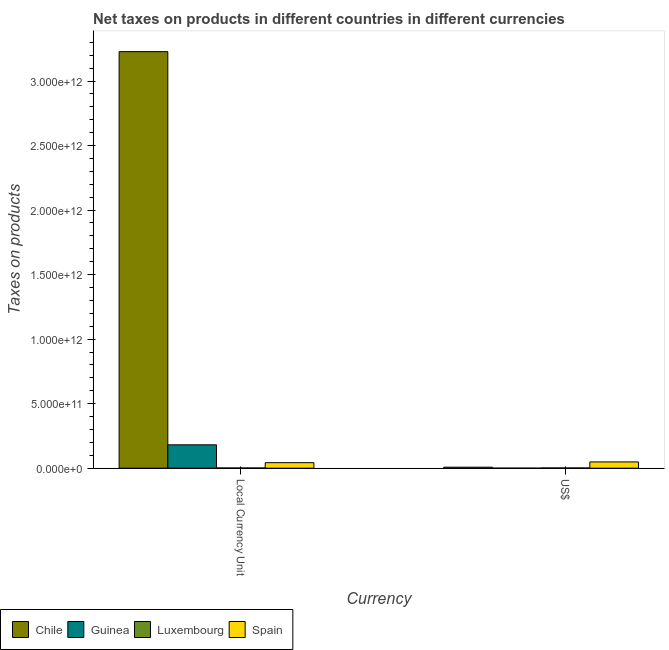How many groups of bars are there?
Your answer should be compact. 2. What is the label of the 2nd group of bars from the left?
Your answer should be very brief. US$. What is the net taxes in us$ in Guinea?
Provide a succinct answer. 1.65e+08. Across all countries, what is the maximum net taxes in us$?
Give a very brief answer. 4.86e+1. Across all countries, what is the minimum net taxes in us$?
Your answer should be very brief. 1.65e+08. In which country was the net taxes in us$ maximum?
Offer a very short reply. Spain. In which country was the net taxes in us$ minimum?
Provide a succinct answer. Guinea. What is the total net taxes in constant 2005 us$ in the graph?
Your response must be concise. 3.45e+12. What is the difference between the net taxes in constant 2005 us$ in Guinea and that in Chile?
Provide a short and direct response. -3.05e+12. What is the difference between the net taxes in us$ in Chile and the net taxes in constant 2005 us$ in Guinea?
Give a very brief answer. -1.73e+11. What is the average net taxes in constant 2005 us$ per country?
Provide a succinct answer. 8.63e+11. What is the difference between the net taxes in us$ and net taxes in constant 2005 us$ in Guinea?
Your answer should be compact. -1.81e+11. In how many countries, is the net taxes in us$ greater than 200000000000 units?
Offer a very short reply. 0. What is the ratio of the net taxes in us$ in Chile to that in Luxembourg?
Ensure brevity in your answer.  4.13. Is the net taxes in constant 2005 us$ in Spain less than that in Guinea?
Ensure brevity in your answer.  Yes. In how many countries, is the net taxes in us$ greater than the average net taxes in us$ taken over all countries?
Give a very brief answer. 1. What does the 1st bar from the left in Local Currency Unit represents?
Keep it short and to the point. Chile. What does the 2nd bar from the right in US$ represents?
Offer a very short reply. Luxembourg. Are all the bars in the graph horizontal?
Keep it short and to the point. No. How many countries are there in the graph?
Your answer should be very brief. 4. What is the difference between two consecutive major ticks on the Y-axis?
Offer a terse response. 5.00e+11. Where does the legend appear in the graph?
Keep it short and to the point. Bottom left. How are the legend labels stacked?
Offer a very short reply. Horizontal. What is the title of the graph?
Provide a succinct answer. Net taxes on products in different countries in different currencies. What is the label or title of the X-axis?
Give a very brief answer. Currency. What is the label or title of the Y-axis?
Offer a very short reply. Taxes on products. What is the Taxes on products in Chile in Local Currency Unit?
Your answer should be compact. 3.23e+12. What is the Taxes on products of Guinea in Local Currency Unit?
Make the answer very short. 1.81e+11. What is the Taxes on products of Luxembourg in Local Currency Unit?
Keep it short and to the point. 1.65e+09. What is the Taxes on products of Spain in Local Currency Unit?
Offer a terse response. 4.27e+1. What is the Taxes on products in Chile in US$?
Make the answer very short. 7.70e+09. What is the Taxes on products in Guinea in US$?
Provide a short and direct response. 1.65e+08. What is the Taxes on products in Luxembourg in US$?
Provide a short and direct response. 1.87e+09. What is the Taxes on products of Spain in US$?
Your answer should be compact. 4.86e+1. Across all Currency, what is the maximum Taxes on products in Chile?
Make the answer very short. 3.23e+12. Across all Currency, what is the maximum Taxes on products of Guinea?
Keep it short and to the point. 1.81e+11. Across all Currency, what is the maximum Taxes on products of Luxembourg?
Ensure brevity in your answer.  1.87e+09. Across all Currency, what is the maximum Taxes on products of Spain?
Ensure brevity in your answer.  4.86e+1. Across all Currency, what is the minimum Taxes on products in Chile?
Keep it short and to the point. 7.70e+09. Across all Currency, what is the minimum Taxes on products of Guinea?
Make the answer very short. 1.65e+08. Across all Currency, what is the minimum Taxes on products in Luxembourg?
Provide a short and direct response. 1.65e+09. Across all Currency, what is the minimum Taxes on products of Spain?
Your answer should be compact. 4.27e+1. What is the total Taxes on products in Chile in the graph?
Provide a succinct answer. 3.24e+12. What is the total Taxes on products of Guinea in the graph?
Keep it short and to the point. 1.81e+11. What is the total Taxes on products of Luxembourg in the graph?
Keep it short and to the point. 3.52e+09. What is the total Taxes on products in Spain in the graph?
Give a very brief answer. 9.13e+1. What is the difference between the Taxes on products of Chile in Local Currency Unit and that in US$?
Provide a succinct answer. 3.22e+12. What is the difference between the Taxes on products in Guinea in Local Currency Unit and that in US$?
Give a very brief answer. 1.81e+11. What is the difference between the Taxes on products of Luxembourg in Local Currency Unit and that in US$?
Your answer should be very brief. -2.11e+08. What is the difference between the Taxes on products of Spain in Local Currency Unit and that in US$?
Keep it short and to the point. -5.83e+09. What is the difference between the Taxes on products of Chile in Local Currency Unit and the Taxes on products of Guinea in US$?
Keep it short and to the point. 3.23e+12. What is the difference between the Taxes on products in Chile in Local Currency Unit and the Taxes on products in Luxembourg in US$?
Keep it short and to the point. 3.23e+12. What is the difference between the Taxes on products of Chile in Local Currency Unit and the Taxes on products of Spain in US$?
Give a very brief answer. 3.18e+12. What is the difference between the Taxes on products of Guinea in Local Currency Unit and the Taxes on products of Luxembourg in US$?
Your answer should be compact. 1.79e+11. What is the difference between the Taxes on products of Guinea in Local Currency Unit and the Taxes on products of Spain in US$?
Provide a short and direct response. 1.33e+11. What is the difference between the Taxes on products in Luxembourg in Local Currency Unit and the Taxes on products in Spain in US$?
Keep it short and to the point. -4.69e+1. What is the average Taxes on products in Chile per Currency?
Make the answer very short. 1.62e+12. What is the average Taxes on products in Guinea per Currency?
Your response must be concise. 9.06e+1. What is the average Taxes on products in Luxembourg per Currency?
Your answer should be compact. 1.76e+09. What is the average Taxes on products of Spain per Currency?
Your answer should be compact. 4.57e+1. What is the difference between the Taxes on products of Chile and Taxes on products of Guinea in Local Currency Unit?
Provide a short and direct response. 3.05e+12. What is the difference between the Taxes on products of Chile and Taxes on products of Luxembourg in Local Currency Unit?
Provide a short and direct response. 3.23e+12. What is the difference between the Taxes on products in Chile and Taxes on products in Spain in Local Currency Unit?
Ensure brevity in your answer.  3.18e+12. What is the difference between the Taxes on products in Guinea and Taxes on products in Luxembourg in Local Currency Unit?
Ensure brevity in your answer.  1.79e+11. What is the difference between the Taxes on products in Guinea and Taxes on products in Spain in Local Currency Unit?
Ensure brevity in your answer.  1.38e+11. What is the difference between the Taxes on products of Luxembourg and Taxes on products of Spain in Local Currency Unit?
Keep it short and to the point. -4.11e+1. What is the difference between the Taxes on products in Chile and Taxes on products in Guinea in US$?
Give a very brief answer. 7.53e+09. What is the difference between the Taxes on products in Chile and Taxes on products in Luxembourg in US$?
Keep it short and to the point. 5.83e+09. What is the difference between the Taxes on products of Chile and Taxes on products of Spain in US$?
Ensure brevity in your answer.  -4.09e+1. What is the difference between the Taxes on products of Guinea and Taxes on products of Luxembourg in US$?
Give a very brief answer. -1.70e+09. What is the difference between the Taxes on products in Guinea and Taxes on products in Spain in US$?
Provide a succinct answer. -4.84e+1. What is the difference between the Taxes on products of Luxembourg and Taxes on products of Spain in US$?
Your response must be concise. -4.67e+1. What is the ratio of the Taxes on products in Chile in Local Currency Unit to that in US$?
Give a very brief answer. 419.31. What is the ratio of the Taxes on products in Guinea in Local Currency Unit to that in US$?
Your response must be concise. 1095.3. What is the ratio of the Taxes on products of Luxembourg in Local Currency Unit to that in US$?
Make the answer very short. 0.89. What is the ratio of the Taxes on products of Spain in Local Currency Unit to that in US$?
Provide a succinct answer. 0.88. What is the difference between the highest and the second highest Taxes on products in Chile?
Offer a very short reply. 3.22e+12. What is the difference between the highest and the second highest Taxes on products of Guinea?
Make the answer very short. 1.81e+11. What is the difference between the highest and the second highest Taxes on products of Luxembourg?
Your response must be concise. 2.11e+08. What is the difference between the highest and the second highest Taxes on products in Spain?
Provide a short and direct response. 5.83e+09. What is the difference between the highest and the lowest Taxes on products of Chile?
Keep it short and to the point. 3.22e+12. What is the difference between the highest and the lowest Taxes on products of Guinea?
Keep it short and to the point. 1.81e+11. What is the difference between the highest and the lowest Taxes on products in Luxembourg?
Make the answer very short. 2.11e+08. What is the difference between the highest and the lowest Taxes on products of Spain?
Provide a short and direct response. 5.83e+09. 